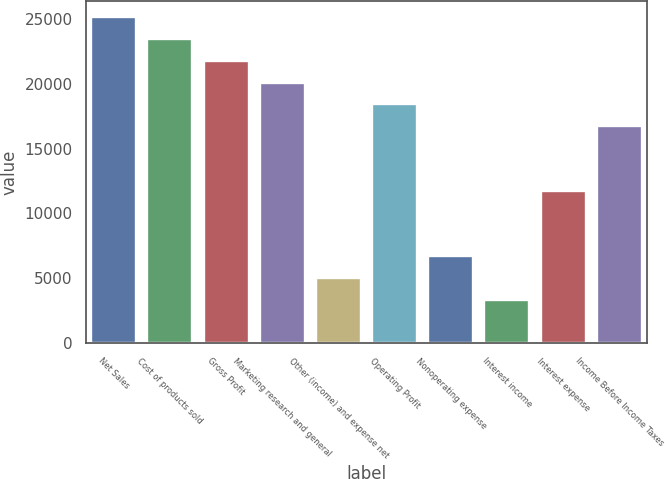Convert chart. <chart><loc_0><loc_0><loc_500><loc_500><bar_chart><fcel>Net Sales<fcel>Cost of products sold<fcel>Gross Profit<fcel>Marketing research and general<fcel>Other (income) and expense net<fcel>Operating Profit<fcel>Nonoperating expense<fcel>Interest income<fcel>Interest expense<fcel>Income Before Income Taxes<nl><fcel>25118.7<fcel>23444.3<fcel>21770<fcel>20095.6<fcel>5026.35<fcel>18421.2<fcel>6700.71<fcel>3351.99<fcel>11723.8<fcel>16746.9<nl></chart> 